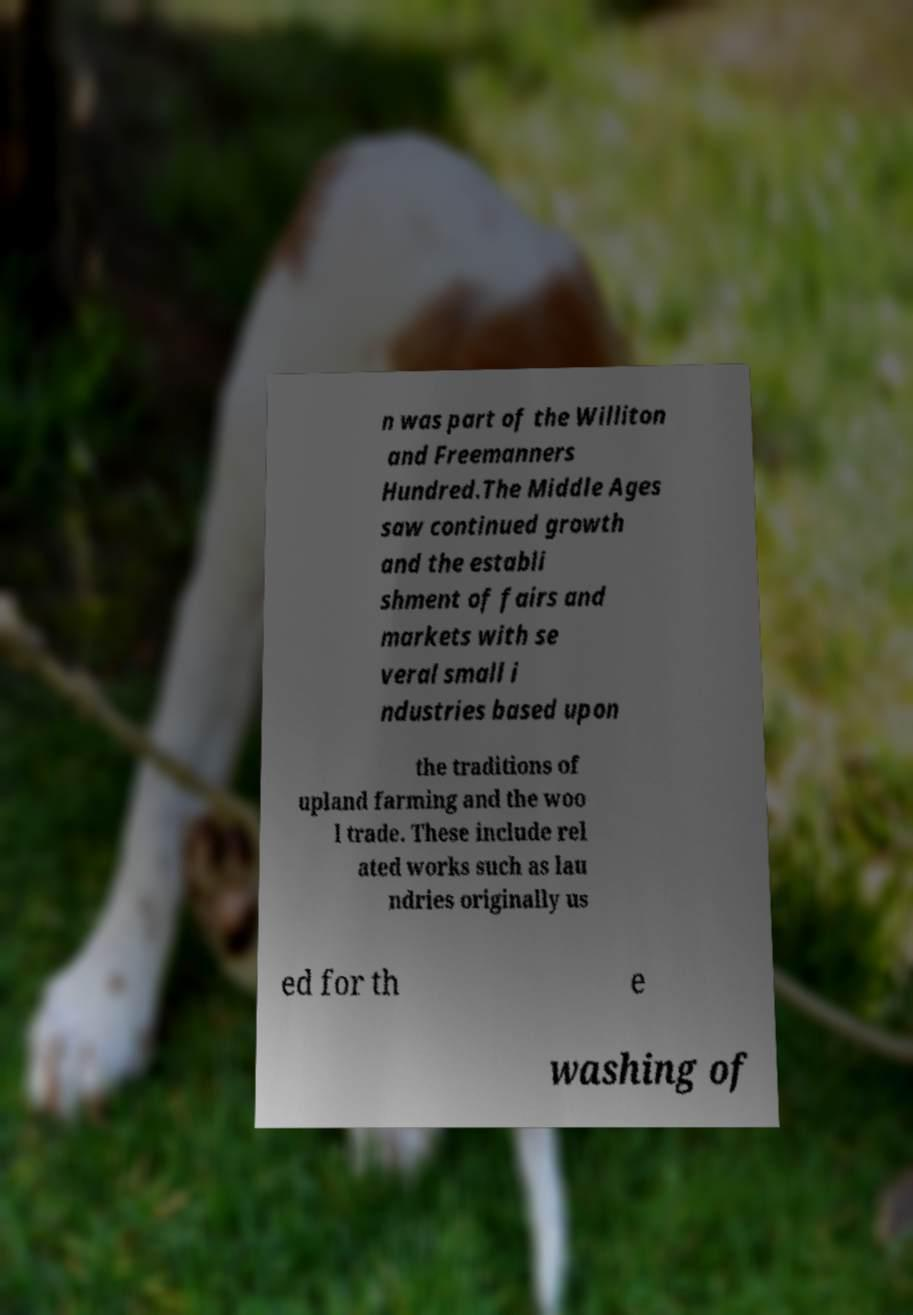For documentation purposes, I need the text within this image transcribed. Could you provide that? n was part of the Williton and Freemanners Hundred.The Middle Ages saw continued growth and the establi shment of fairs and markets with se veral small i ndustries based upon the traditions of upland farming and the woo l trade. These include rel ated works such as lau ndries originally us ed for th e washing of 